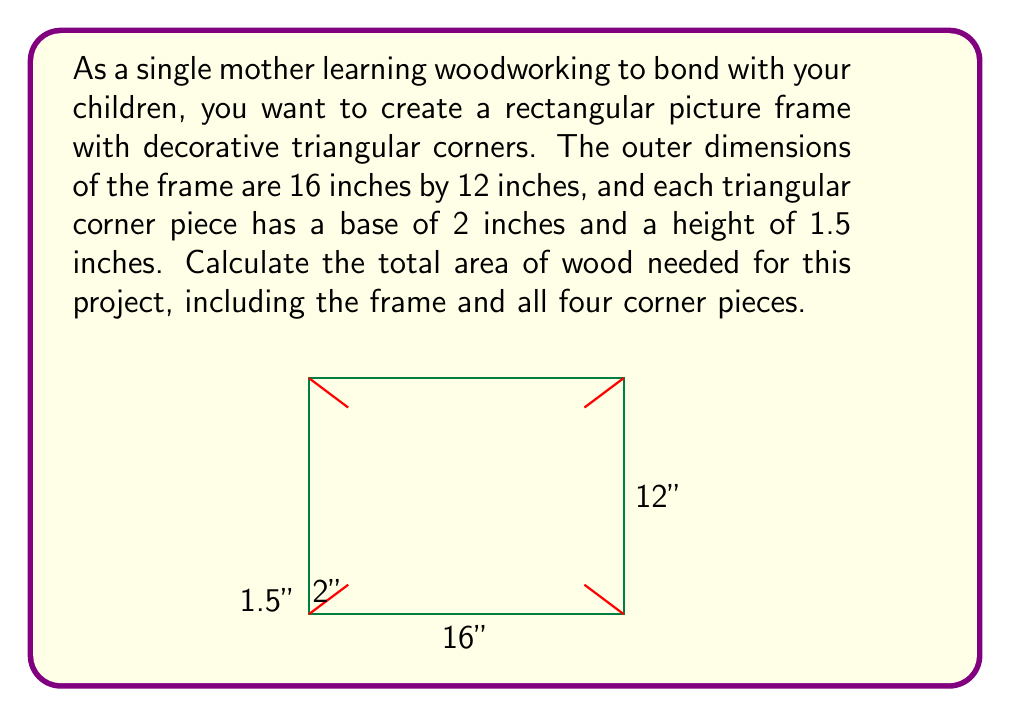What is the answer to this math problem? Let's break this problem down into steps:

1) First, calculate the area of the rectangular frame:
   $$A_{rectangle} = length \times width = 16 \text{ inches} \times 12 \text{ inches} = 192 \text{ square inches}$$

2) Next, calculate the area of one triangular corner piece:
   $$A_{triangle} = \frac{1}{2} \times base \times height = \frac{1}{2} \times 2 \text{ inches} \times 1.5 \text{ inches} = 1.5 \text{ square inches}$$

3) There are four corner pieces, so the total area of the corner pieces is:
   $$A_{corners} = 4 \times 1.5 \text{ square inches} = 6 \text{ square inches}$$

4) The total area needed is the sum of the rectangle and the corner pieces:
   $$A_{total} = A_{rectangle} + A_{corners} = 192 \text{ square inches} + 6 \text{ square inches} = 198 \text{ square inches}$$

This calculation gives you the total area of wood needed for your picture frame project.
Answer: The total area of wood needed for the picture frame project is $198 \text{ square inches}$. 